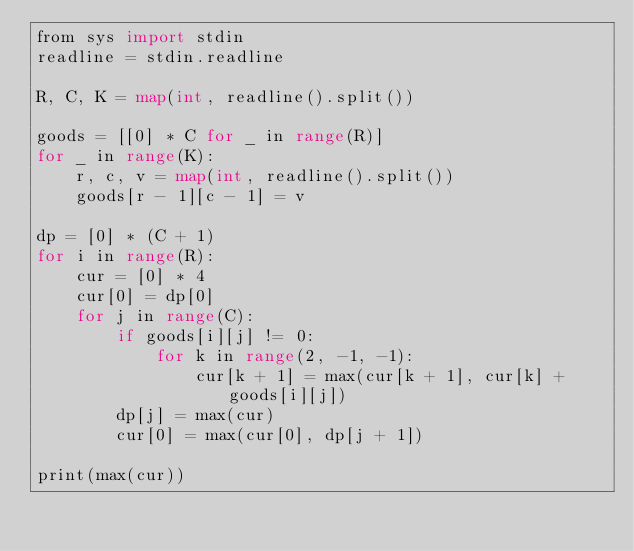<code> <loc_0><loc_0><loc_500><loc_500><_Go_>from sys import stdin
readline = stdin.readline

R, C, K = map(int, readline().split())

goods = [[0] * C for _ in range(R)]
for _ in range(K):
    r, c, v = map(int, readline().split())
    goods[r - 1][c - 1] = v

dp = [0] * (C + 1)
for i in range(R):
    cur = [0] * 4
    cur[0] = dp[0]
    for j in range(C):
        if goods[i][j] != 0:
            for k in range(2, -1, -1):
                cur[k + 1] = max(cur[k + 1], cur[k] + goods[i][j])
        dp[j] = max(cur)
        cur[0] = max(cur[0], dp[j + 1])

print(max(cur))
</code> 